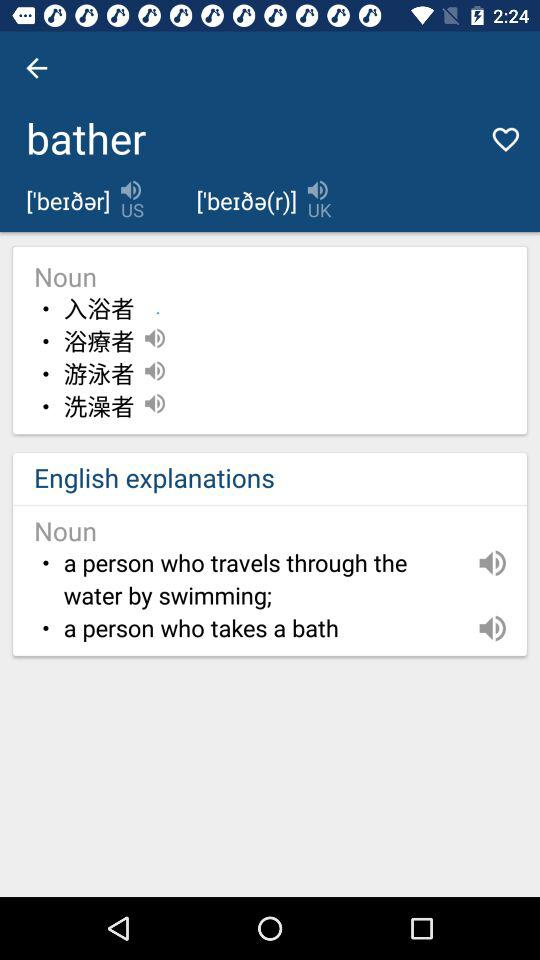What is the meaning of bather in the sense of a noun? The meaning of bather in the sense of a noun is "a person who travels through the water by swimming;" and "a person who takes a bath". 